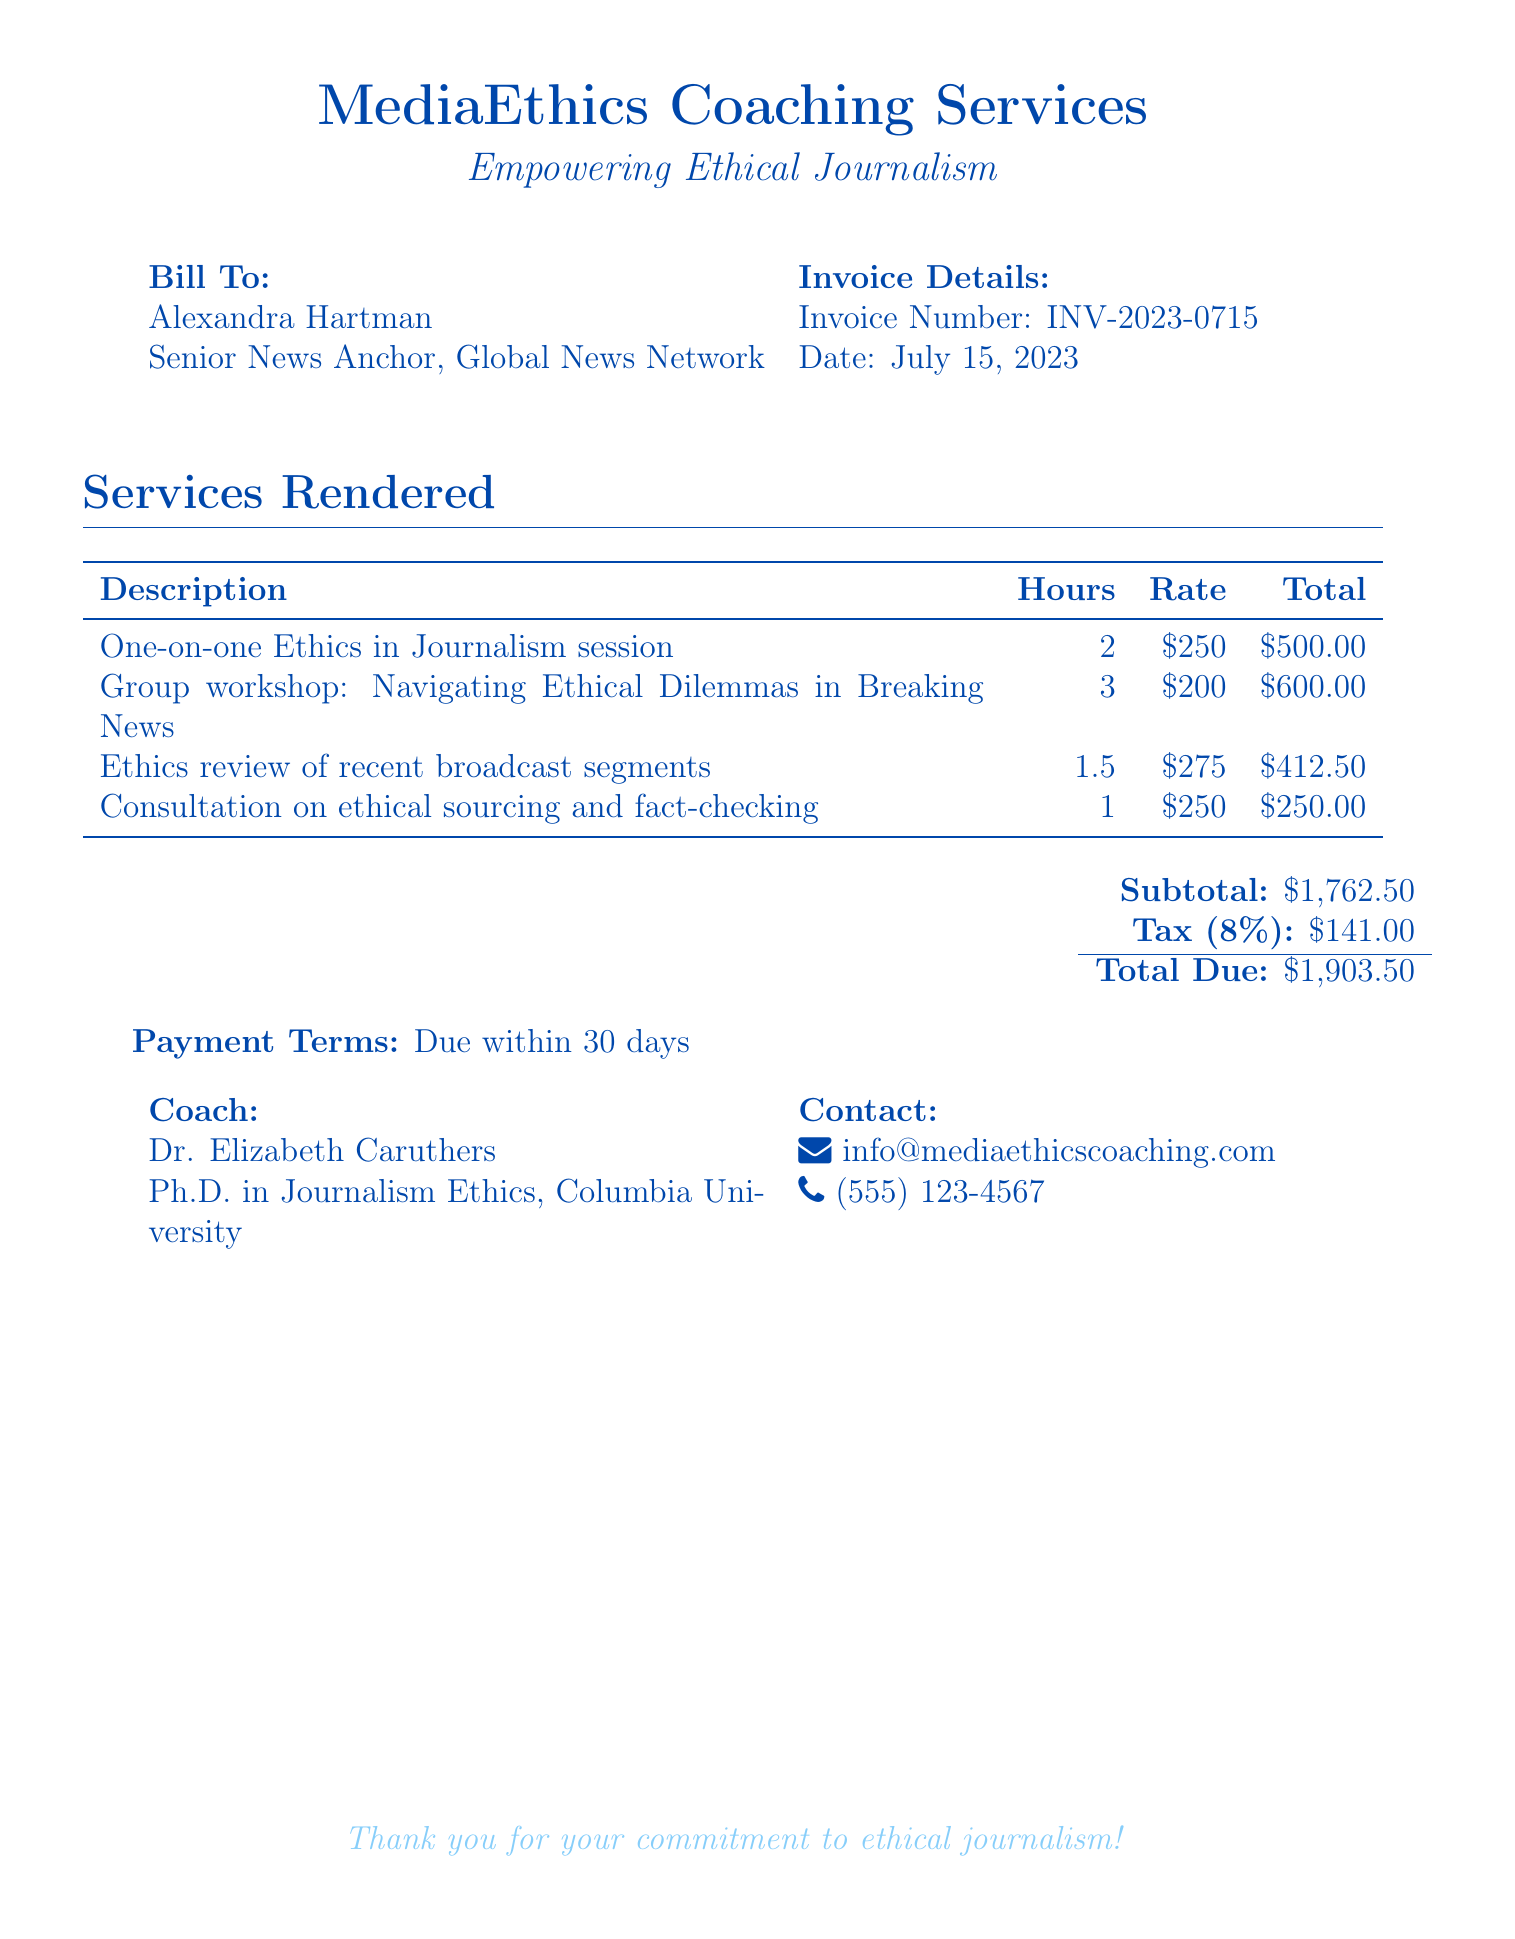What is the invoice number? The invoice number is specifically stated in the document as INV-2023-0715.
Answer: INV-2023-0715 Who is the coach? The coach listed in the document is Dr. Elizabeth Caruthers.
Answer: Dr. Elizabeth Caruthers What is the total amount due? The total amount due is calculated as the subtotal plus tax, which in this case is $1,903.50.
Answer: $1,903.50 How many hours were spent on the group workshop? The document details that the group workshop took 3 hours.
Answer: 3 What is the tax rate applied? The tax rate mentioned in the document is 8%.
Answer: 8% What is the primary focus of the coaching service? The document states the coaching service focuses on "Empowering Ethical Journalism."
Answer: Empowering Ethical Journalism What is the subtotal before tax? The subtotal before tax is provided as $1,762.50 in the document.
Answer: $1,762.50 When is payment due? The document specifies that payment is due within 30 days.
Answer: 30 days What type of session was held for ethics in journalism? The document includes a "One-on-one Ethics in Journalism session" as a type of service rendered.
Answer: One-on-one Ethics in Journalism session 